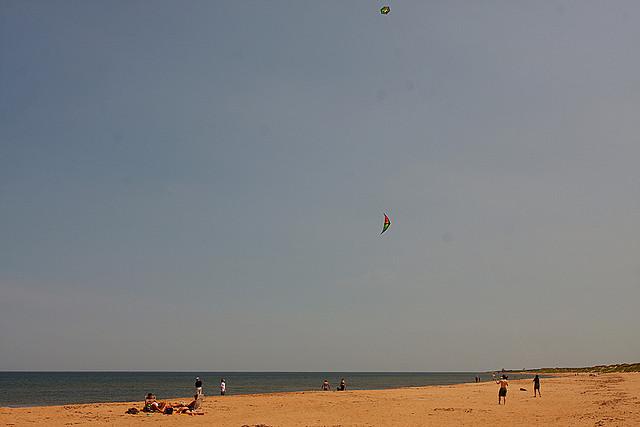Are they at a lake or the ocean?
Keep it brief. Ocean. Is the sky clear or cloudy?
Keep it brief. Clear. Are the people standing in water?
Concise answer only. No. Is the kite high?
Quick response, please. Yes. 